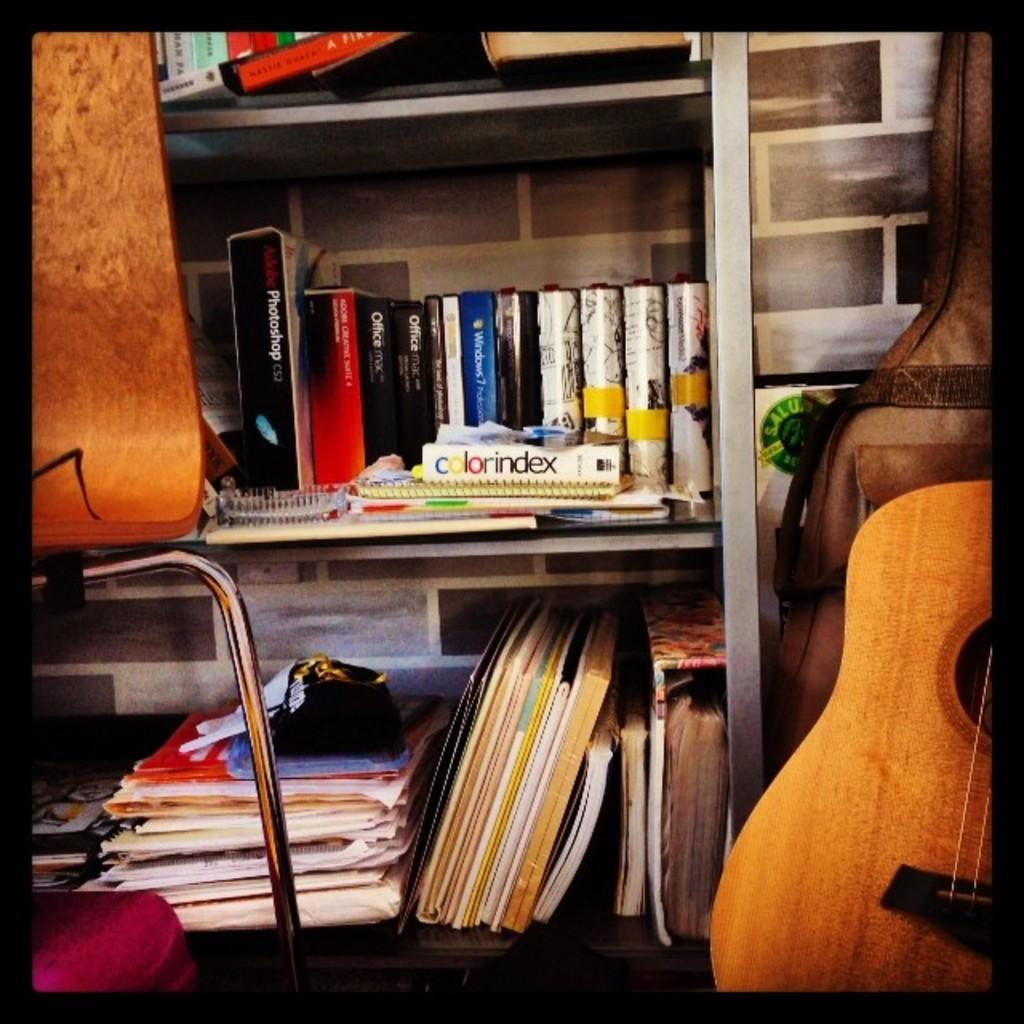<image>
Relay a brief, clear account of the picture shown. a book that has the word index on it 